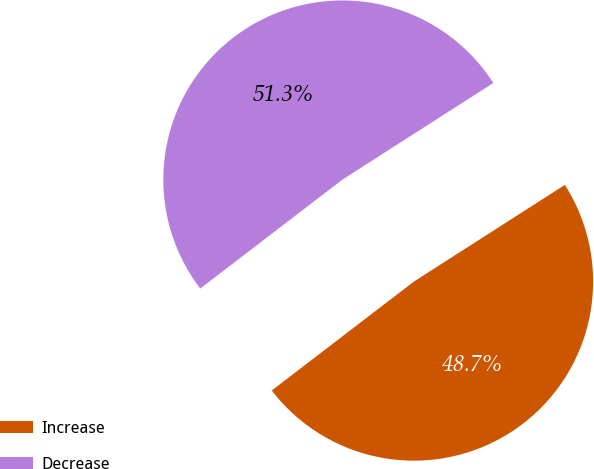Convert chart to OTSL. <chart><loc_0><loc_0><loc_500><loc_500><pie_chart><fcel>Increase<fcel>Decrease<nl><fcel>48.66%<fcel>51.34%<nl></chart> 